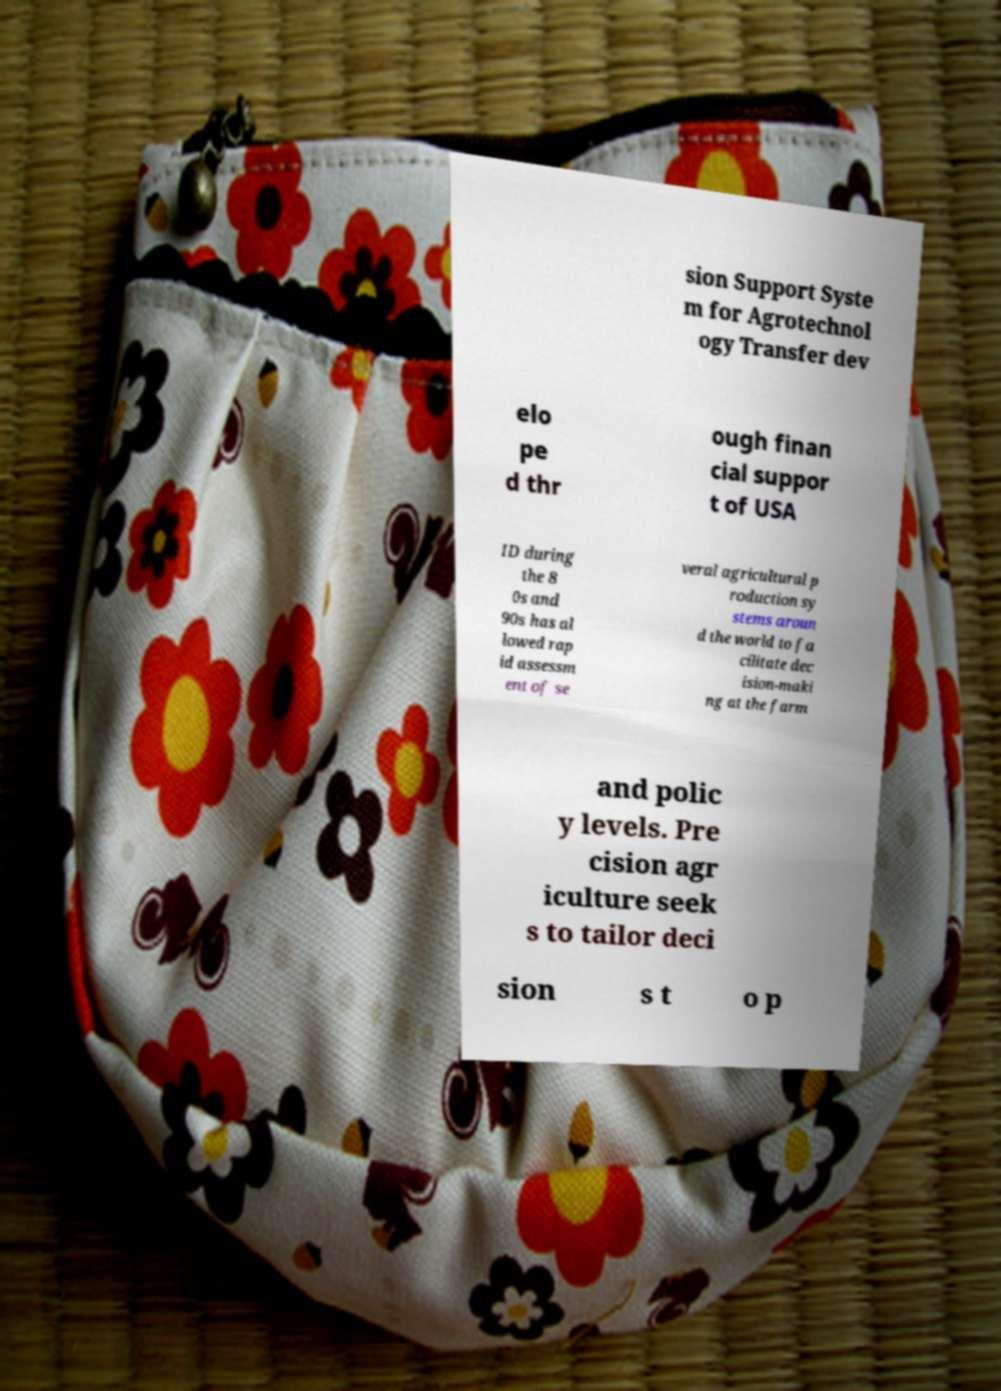For documentation purposes, I need the text within this image transcribed. Could you provide that? sion Support Syste m for Agrotechnol ogy Transfer dev elo pe d thr ough finan cial suppor t of USA ID during the 8 0s and 90s has al lowed rap id assessm ent of se veral agricultural p roduction sy stems aroun d the world to fa cilitate dec ision-maki ng at the farm and polic y levels. Pre cision agr iculture seek s to tailor deci sion s t o p 